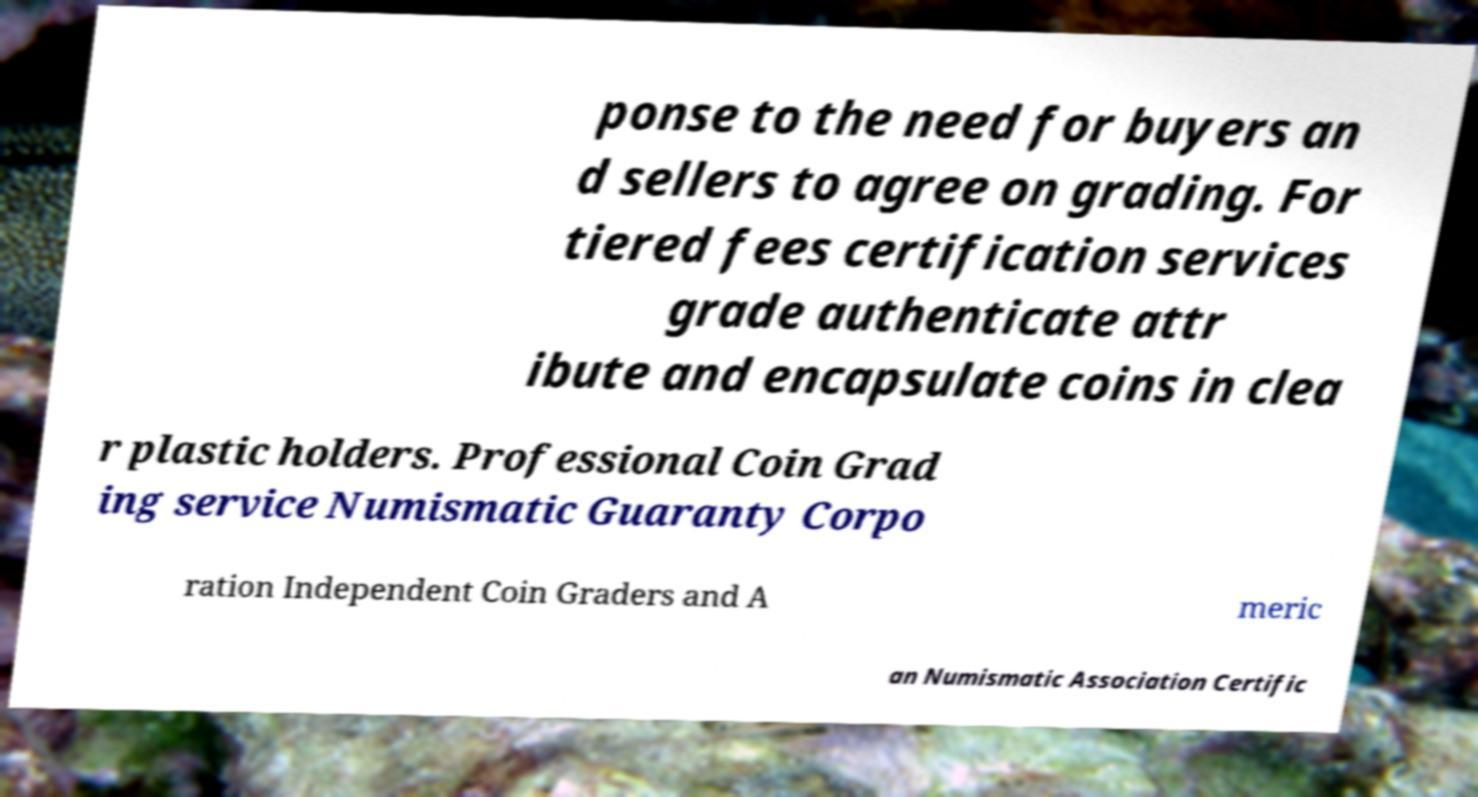There's text embedded in this image that I need extracted. Can you transcribe it verbatim? ponse to the need for buyers an d sellers to agree on grading. For tiered fees certification services grade authenticate attr ibute and encapsulate coins in clea r plastic holders. Professional Coin Grad ing service Numismatic Guaranty Corpo ration Independent Coin Graders and A meric an Numismatic Association Certific 